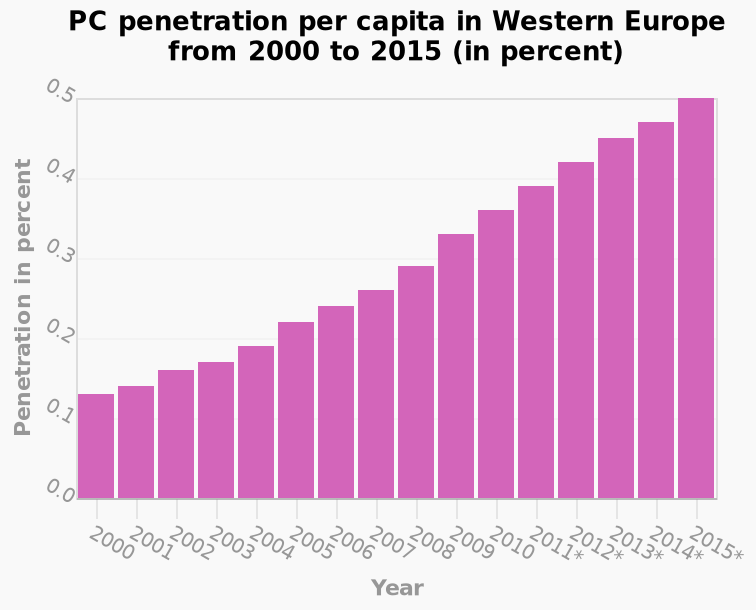<image>
What does the y-axis represent on the bar plot?   The y-axis represents PC penetration per capita in percent. When did the increase in PC penetration per capita in western Europe reach its peak?  The increase in PC penetration per capita in western Europe reached its peak in 2015. What is the range of the x-axis values?   The range of the x-axis values is from 2000 to 2015. 